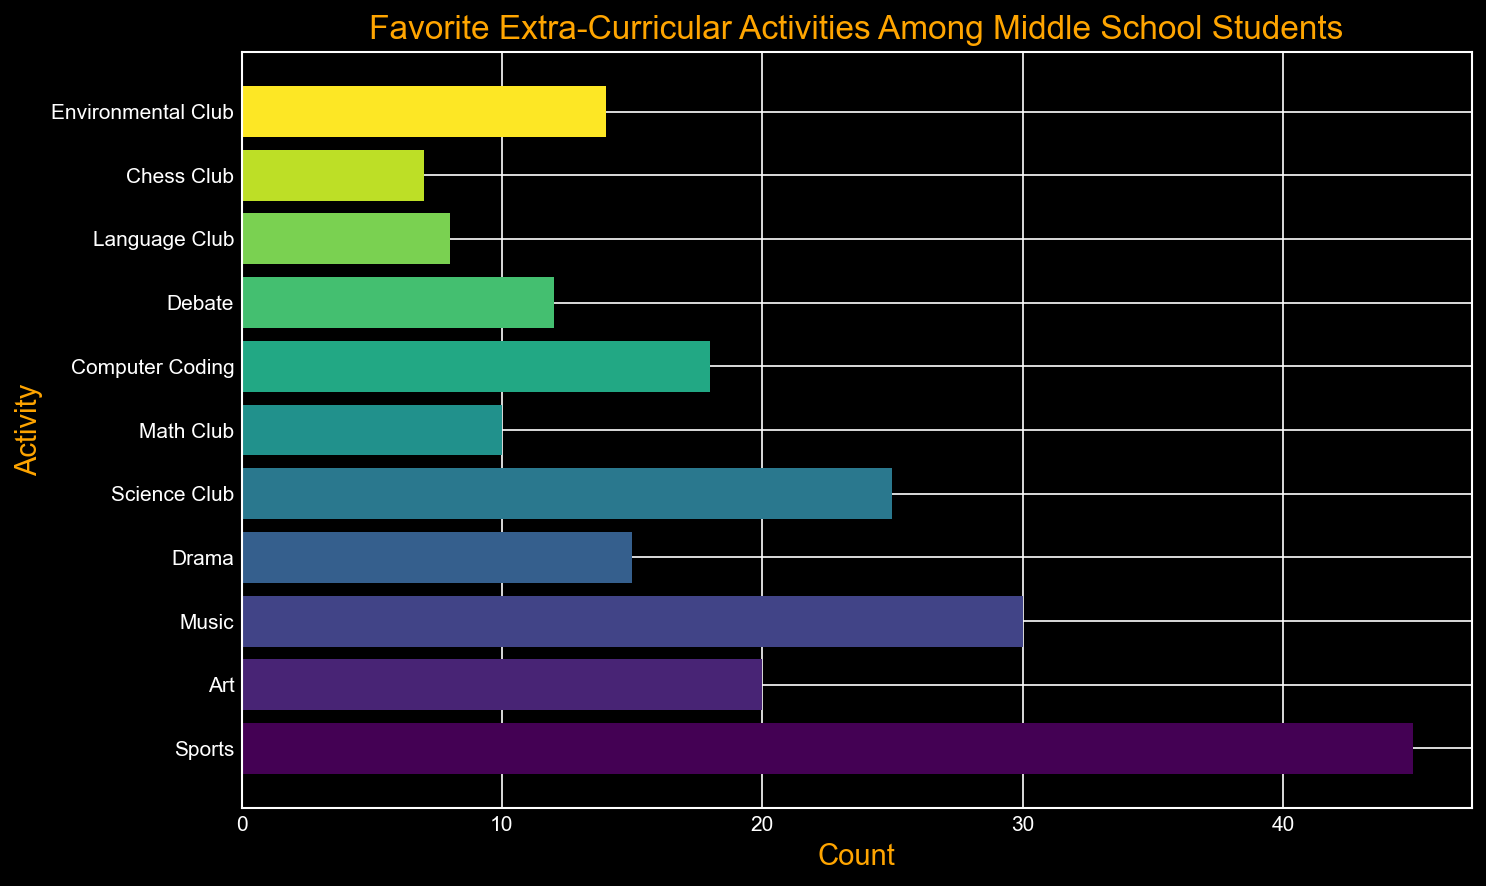What is the most popular extra-curricular activity among middle school students? By looking at the figure, we can see that the activity with the highest count (bar length) is the most popular. The bar corresponding to "Sports" is the longest, indicating its popularity.
Answer: Sports Which activity has a larger count, Music or Art? We compare the lengths of the bars representing Music and Art. The bar for Music is longer than the bar for Art.
Answer: Music Which extra-curricular activity has the lowest count? The bar corresponding to the "Chess Club" is the shortest, indicating it has the lowest count among all listed activities.
Answer: Chess Club What is the combined count of Science Club and Math Club students? We sum the counts for Science Club and Math Club. Science Club has 25 students, and Math Club has 10 students. Adding them together, 25 + 10 = 35.
Answer: 35 Are there more students in Drama or Debate? By comparing the lengths of the bars, we see that Drama's bar is longer than Debate's bar, indicating more students are involved in Drama.
Answer: Drama How many more students participate in Sports than in Environmental Club? We subtract the count for Environmental Club from the count for Sports. Sports has 45 students, and Environmental Club has 14 students. The difference is 45 - 14 = 31.
Answer: 31 Which extra-curricular activity has an average count between Debate and Music? To find the average count between Debate (12) and Music (30), we calculate (12 + 30) / 2 = 21. The activity with a count closest to 21 is Art, with a count of 20.
Answer: Art Is the count of students in Computer Coding closer to that of Science Club or Math Club? The count for Computer Coding is 18. The count for Science Club is 25 and for Math Club is 10. The difference with Science Club is 25 - 18 = 7 and with Math Club is 18 - 10 = 8. Since 7 is smaller than 8, the count for Computer Coding is closer to Science Club.
Answer: Science Club 